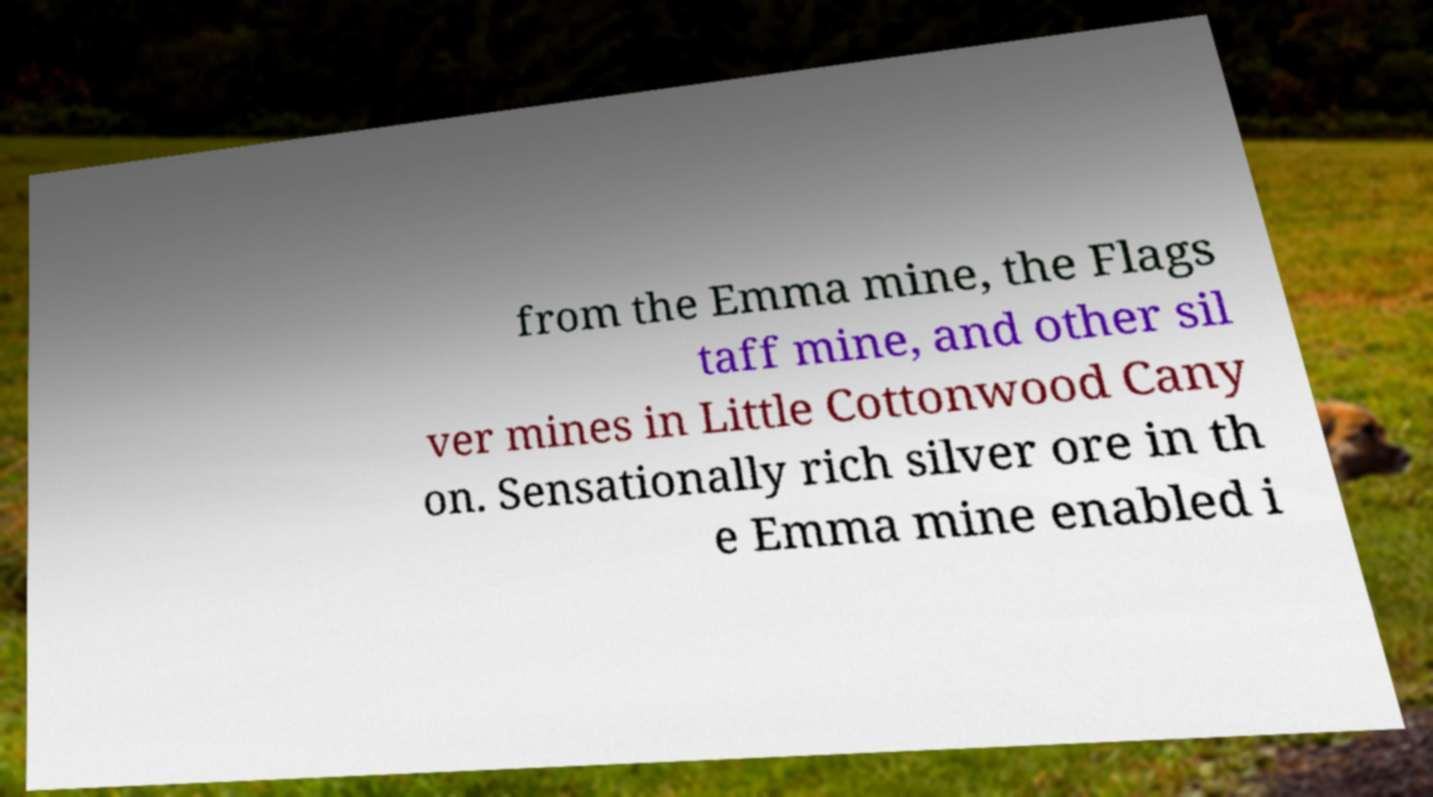There's text embedded in this image that I need extracted. Can you transcribe it verbatim? from the Emma mine, the Flags taff mine, and other sil ver mines in Little Cottonwood Cany on. Sensationally rich silver ore in th e Emma mine enabled i 